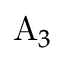Convert formula to latex. <formula><loc_0><loc_0><loc_500><loc_500>A _ { 3 }</formula> 